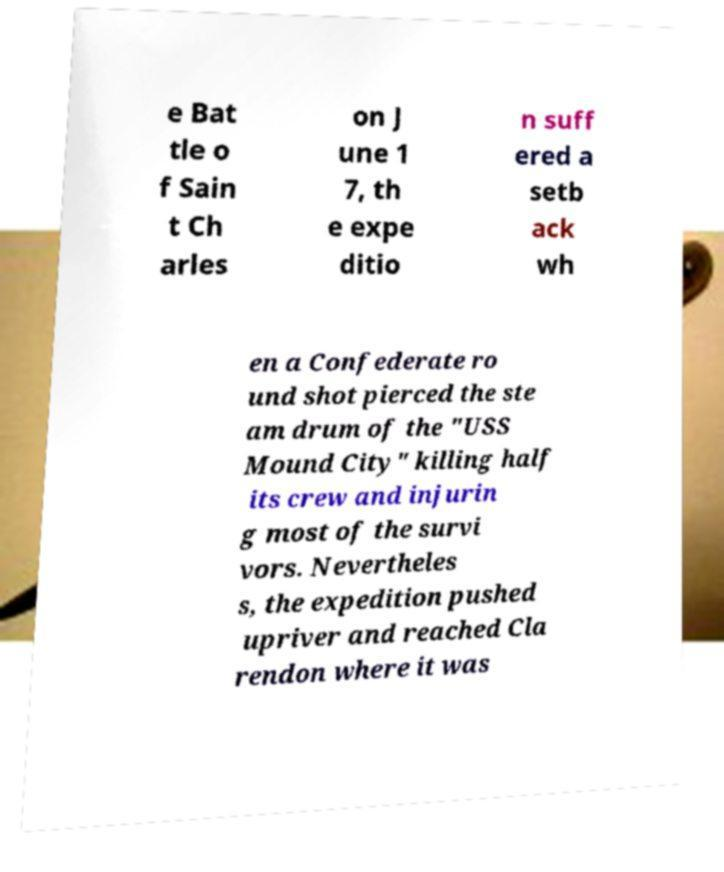Can you accurately transcribe the text from the provided image for me? e Bat tle o f Sain t Ch arles on J une 1 7, th e expe ditio n suff ered a setb ack wh en a Confederate ro und shot pierced the ste am drum of the "USS Mound City" killing half its crew and injurin g most of the survi vors. Nevertheles s, the expedition pushed upriver and reached Cla rendon where it was 